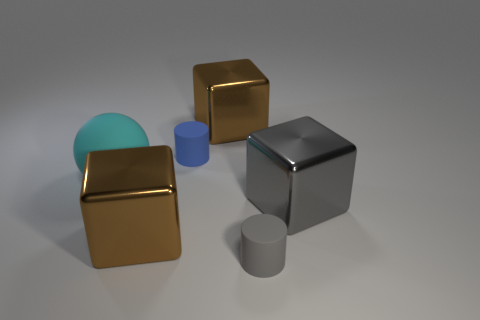Subtract all brown metal cubes. How many cubes are left? 1 Subtract all red cylinders. How many brown blocks are left? 2 Add 1 blue matte cylinders. How many objects exist? 7 Subtract all gray cubes. How many cubes are left? 2 Subtract 1 cubes. How many cubes are left? 2 Subtract all spheres. How many objects are left? 5 Subtract all yellow blocks. Subtract all cyan balls. How many blocks are left? 3 Subtract all large metal objects. Subtract all small matte things. How many objects are left? 1 Add 6 small rubber cylinders. How many small rubber cylinders are left? 8 Add 4 blue objects. How many blue objects exist? 5 